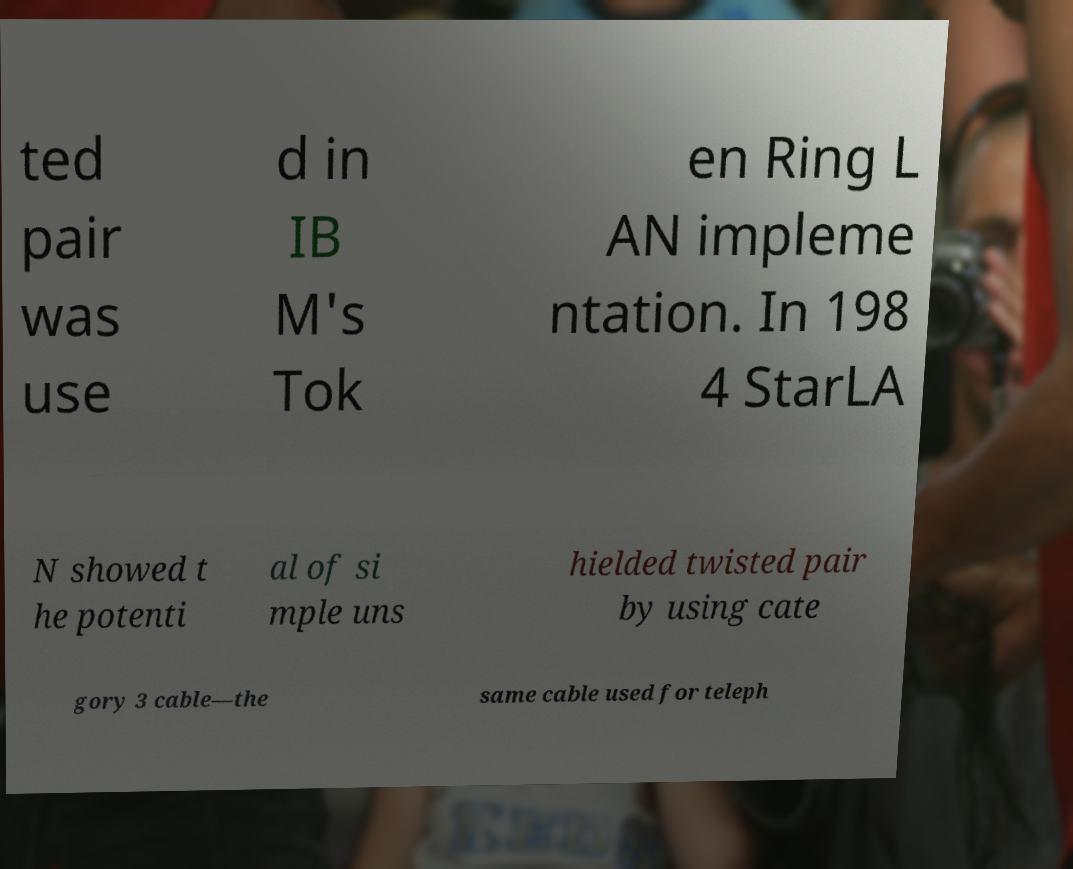Can you accurately transcribe the text from the provided image for me? ted pair was use d in IB M's Tok en Ring L AN impleme ntation. In 198 4 StarLA N showed t he potenti al of si mple uns hielded twisted pair by using cate gory 3 cable—the same cable used for teleph 